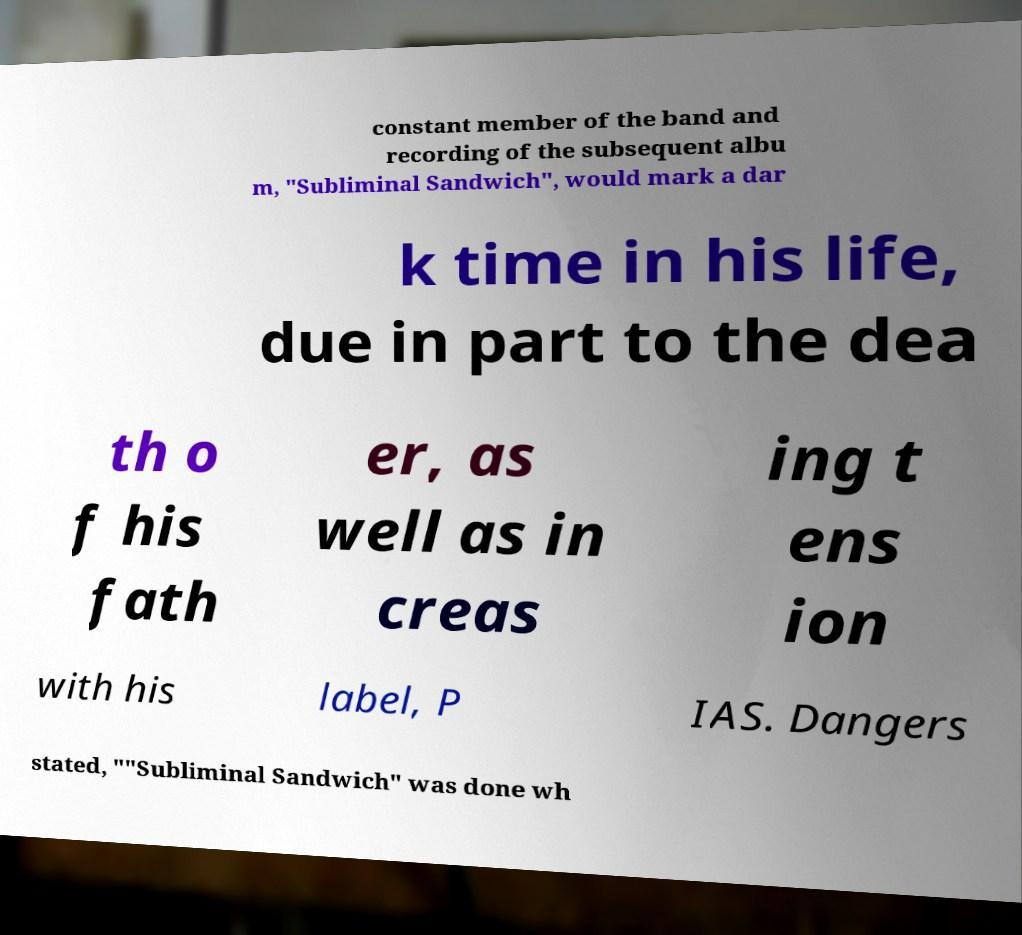Can you read and provide the text displayed in the image?This photo seems to have some interesting text. Can you extract and type it out for me? constant member of the band and recording of the subsequent albu m, "Subliminal Sandwich", would mark a dar k time in his life, due in part to the dea th o f his fath er, as well as in creas ing t ens ion with his label, P IAS. Dangers stated, ""Subliminal Sandwich" was done wh 